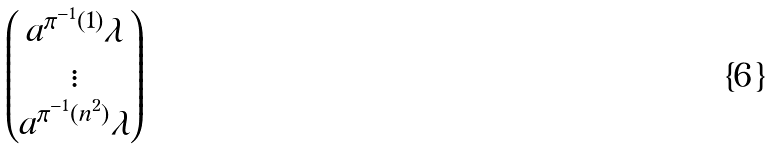Convert formula to latex. <formula><loc_0><loc_0><loc_500><loc_500>\begin{pmatrix} a ^ { \pi ^ { - 1 } ( 1 ) } \lambda \\ \vdots \\ a ^ { \pi ^ { - 1 } ( n ^ { 2 } ) } \lambda \end{pmatrix}</formula> 